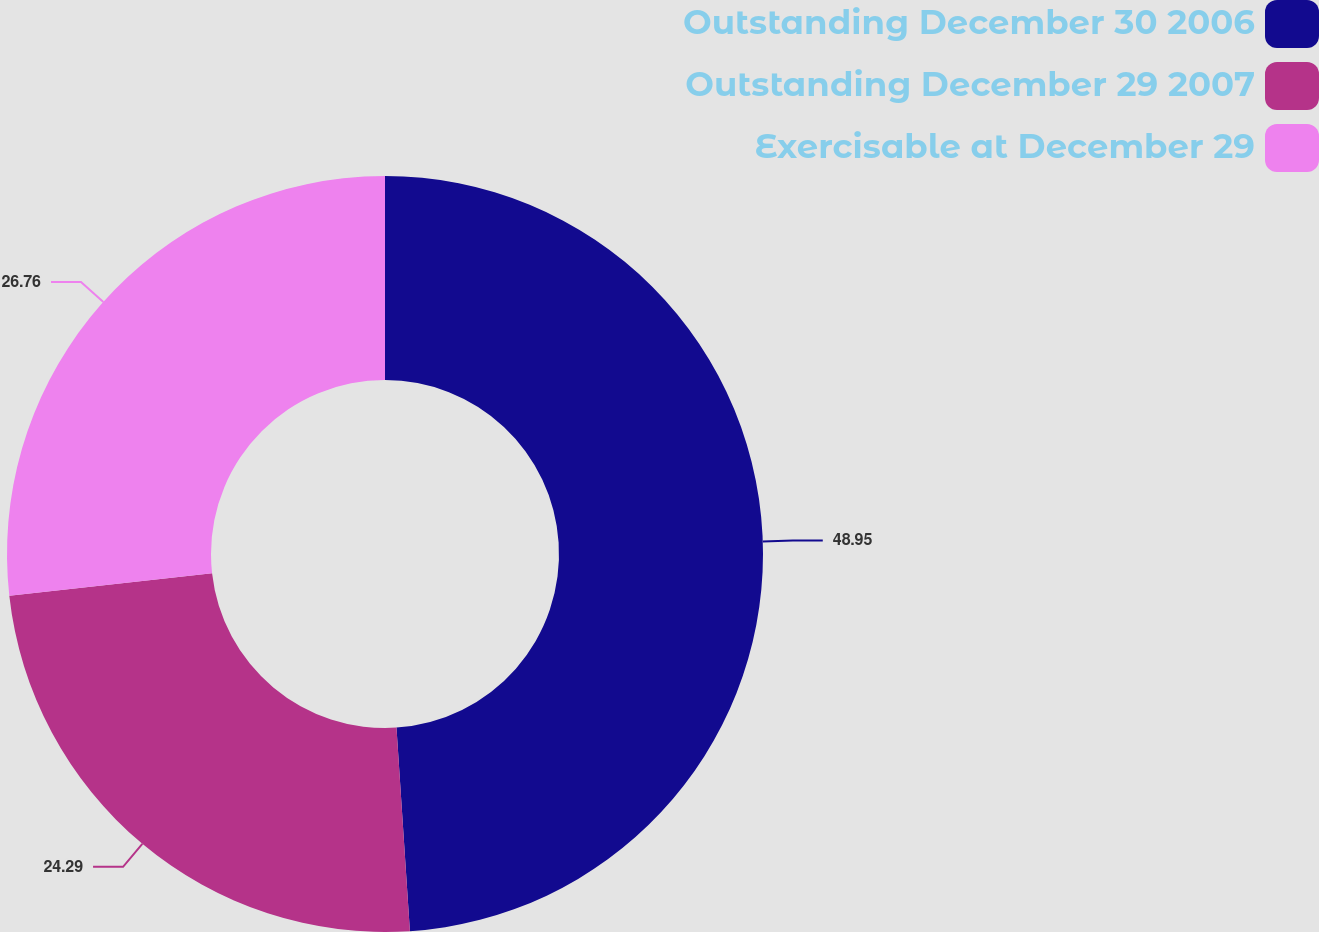Convert chart. <chart><loc_0><loc_0><loc_500><loc_500><pie_chart><fcel>Outstanding December 30 2006<fcel>Outstanding December 29 2007<fcel>Exercisable at December 29<nl><fcel>48.95%<fcel>24.29%<fcel>26.76%<nl></chart> 